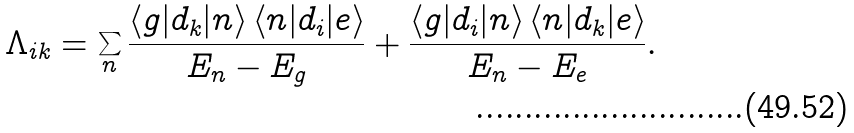Convert formula to latex. <formula><loc_0><loc_0><loc_500><loc_500>\Lambda _ { i k } = \sum _ { n } \frac { \left \langle g | d _ { k } | n \right \rangle \left \langle n | d _ { i } | e \right \rangle } { E _ { n } - E _ { g } } + \frac { \left \langle g | d _ { i } | n \right \rangle \left \langle n | d _ { k } | e \right \rangle } { E _ { n } - E _ { e } } .</formula> 